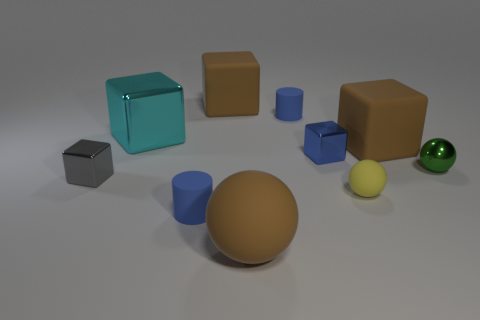There is a large brown block in front of the tiny rubber cylinder that is behind the cyan block; are there any big cyan metallic cubes that are to the left of it?
Make the answer very short. Yes. There is a big shiny object; are there any blue shiny cubes behind it?
Your response must be concise. No. What number of cylinders have the same color as the metal ball?
Keep it short and to the point. 0. The cyan block that is the same material as the tiny gray thing is what size?
Provide a short and direct response. Large. There is a brown rubber block that is on the left side of the rubber ball that is in front of the rubber ball behind the large brown sphere; what size is it?
Offer a very short reply. Large. How big is the brown object in front of the tiny yellow matte sphere?
Make the answer very short. Large. What number of purple objects are either tiny metal blocks or small matte cylinders?
Give a very brief answer. 0. Is there a metal block of the same size as the blue metal thing?
Make the answer very short. Yes. What is the material of the ball that is the same size as the green metal thing?
Ensure brevity in your answer.  Rubber. There is a sphere that is on the left side of the tiny rubber ball; is it the same size as the rubber cylinder behind the tiny green shiny object?
Offer a terse response. No. 